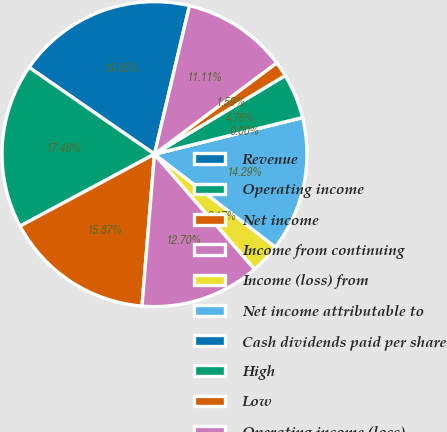<chart> <loc_0><loc_0><loc_500><loc_500><pie_chart><fcel>Revenue<fcel>Operating income<fcel>Net income<fcel>Income from continuing<fcel>Income (loss) from<fcel>Net income attributable to<fcel>Cash dividends paid per share<fcel>High<fcel>Low<fcel>Operating income (loss)<nl><fcel>19.05%<fcel>17.46%<fcel>15.87%<fcel>12.7%<fcel>3.17%<fcel>14.29%<fcel>0.0%<fcel>4.76%<fcel>1.59%<fcel>11.11%<nl></chart> 